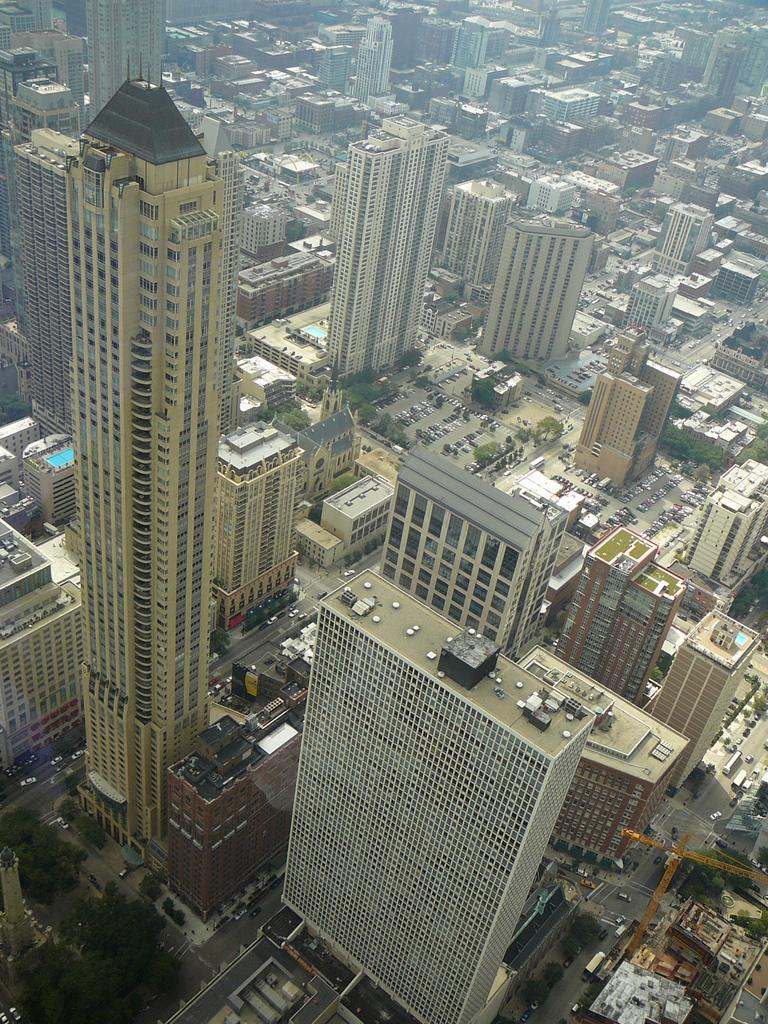What type of location is shown in the image? The image depicts a city. What are some of the prominent features of the city? There are big towers and buildings in the city, as well as roads between the buildings. Are there any natural elements present in the city? Yes, there are trees in the city. How would you describe the overall development of the city? The city appears to be well developed. Can you feel the comfort of the rat in the image? There is no rat present in the image, so it is not possible to determine its comfort level. 